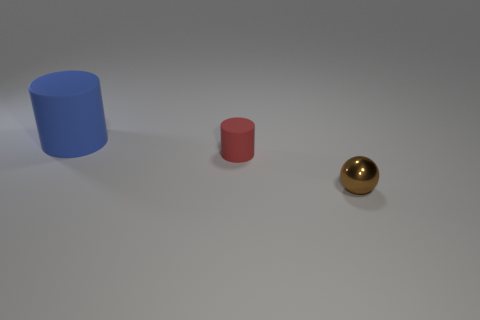Add 3 large blue rubber things. How many objects exist? 6 Subtract all cylinders. How many objects are left? 1 Subtract all small blue cylinders. Subtract all brown balls. How many objects are left? 2 Add 2 tiny brown metal spheres. How many tiny brown metal spheres are left? 3 Add 3 brown things. How many brown things exist? 4 Subtract 0 gray balls. How many objects are left? 3 